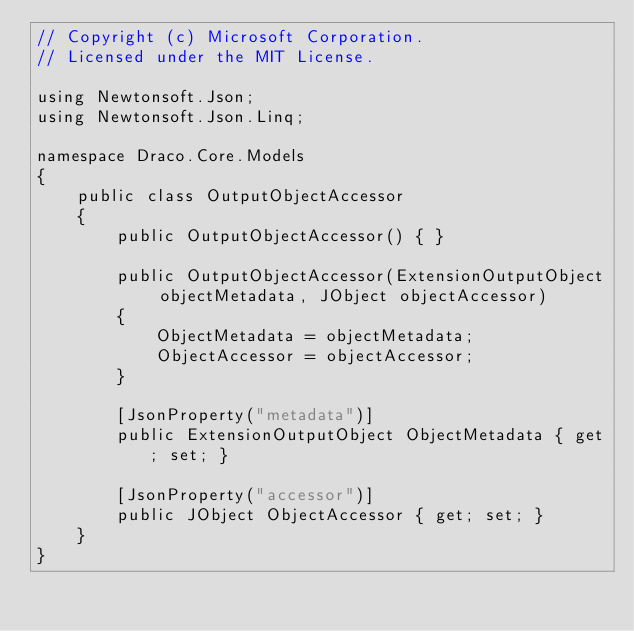<code> <loc_0><loc_0><loc_500><loc_500><_C#_>// Copyright (c) Microsoft Corporation.
// Licensed under the MIT License.

using Newtonsoft.Json;
using Newtonsoft.Json.Linq;

namespace Draco.Core.Models
{
    public class OutputObjectAccessor
    {
        public OutputObjectAccessor() { }

        public OutputObjectAccessor(ExtensionOutputObject objectMetadata, JObject objectAccessor)
        {
            ObjectMetadata = objectMetadata;
            ObjectAccessor = objectAccessor;
        }

        [JsonProperty("metadata")]
        public ExtensionOutputObject ObjectMetadata { get; set; }

        [JsonProperty("accessor")]
        public JObject ObjectAccessor { get; set; }
    }
}
</code> 